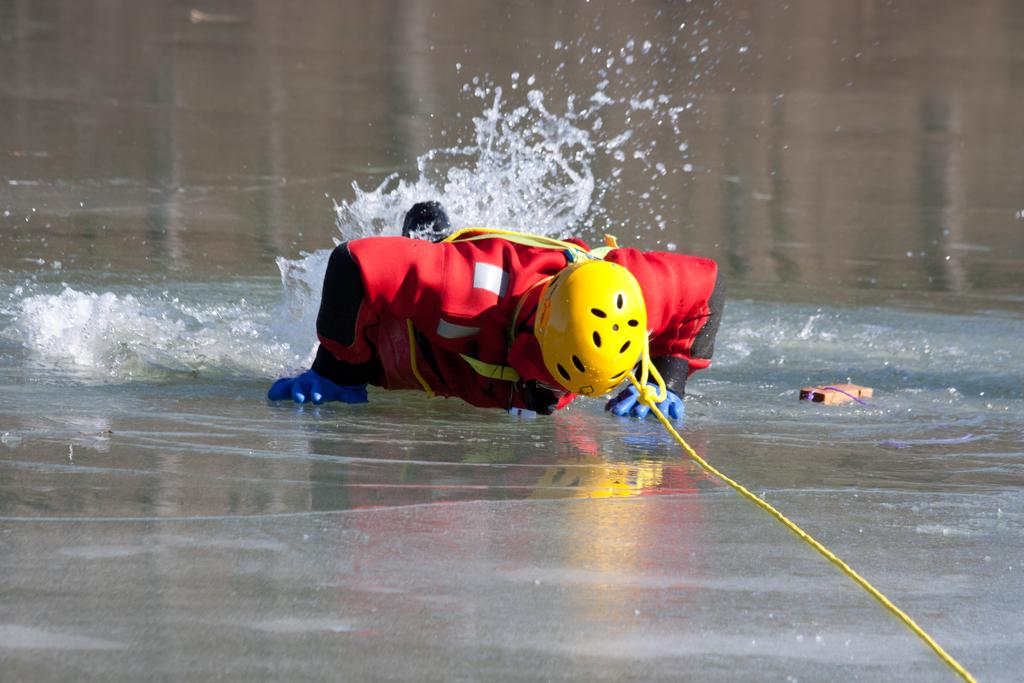What is the position of the person in the image? There is a person lying on the ground in the image. What object can be seen in the image besides the person? There is a rope in the image. What can be seen in the background of the image? There is water visible in the background of the image. What type of dinner is being served in the image? There is no dinner present in the image; it features a person lying on the ground and a rope. What emotion is the person expressing towards the rope in the image? The image does not show any emotions or expressions, so it cannot be determined how the person feels about the rope. 